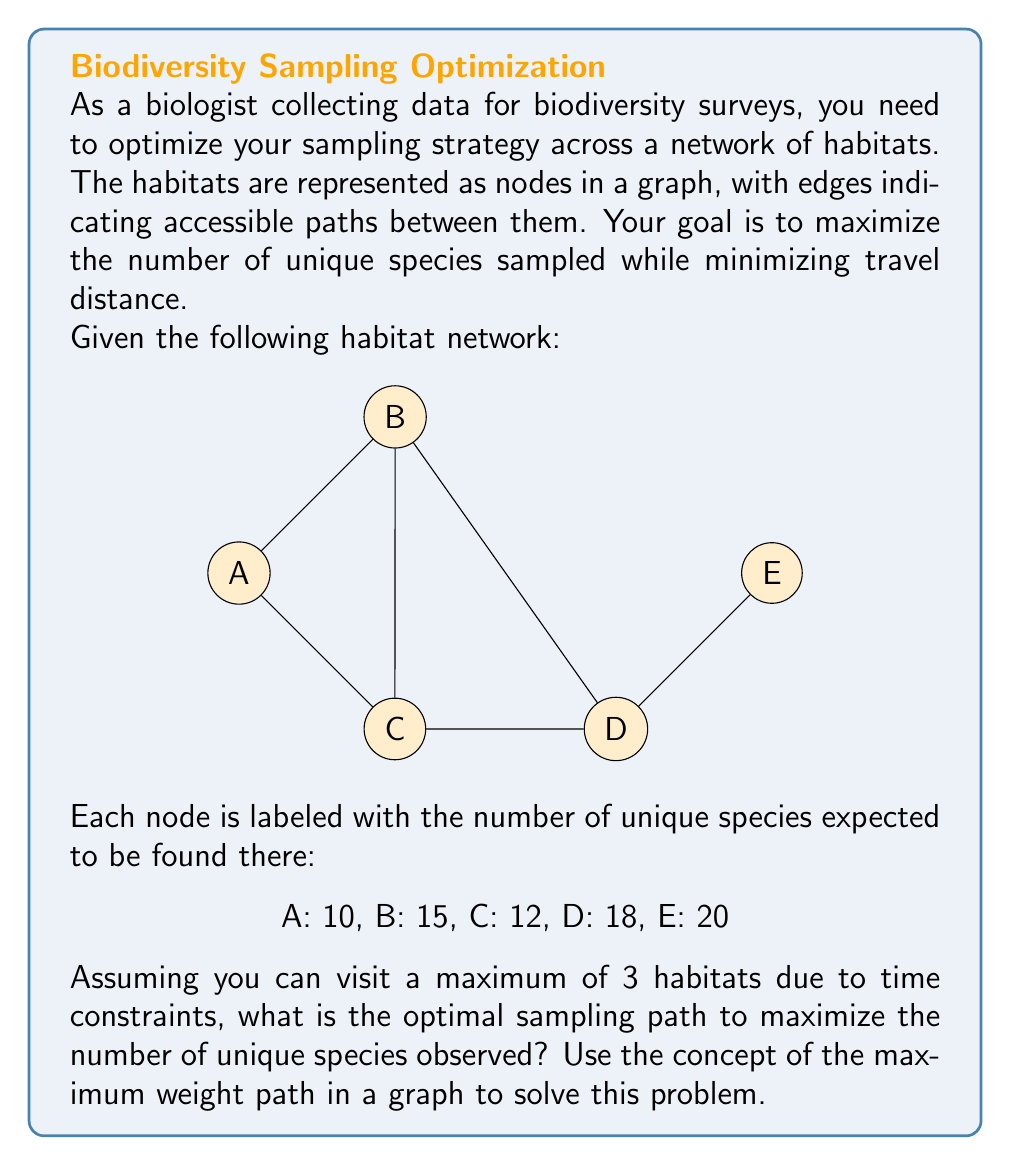Can you solve this math problem? To solve this problem, we'll use the concept of the maximum weight path in a graph. Here's a step-by-step approach:

1) First, we need to create a weighted graph where the weights represent the number of unique species at each node.

2) Since we can only visit 3 habitats, we're looking for the path of length 2 (3 nodes) with the maximum total weight.

3) Let's list all possible paths of length 2:
   A-B-D, A-B-E, A-C-D, B-C-D, B-D-E, C-D-E

4) Now, let's calculate the total weight (number of species) for each path:
   A-B-D: 10 + 15 + 18 = 43
   A-B-E: 10 + 15 + 20 = 45
   A-C-D: 10 + 12 + 18 = 40
   B-C-D: 15 + 12 + 18 = 45
   B-D-E: 15 + 18 + 20 = 53
   C-D-E: 12 + 18 + 20 = 50

5) The path with the maximum weight is B-D-E, with a total of 53 unique species.

6) This path can be represented mathematically as:

   $$P_{max} = \arg\max_{P \in \text{Paths}} \sum_{v \in P} w(v)$$

   where $P_{max}$ is the optimal path, Paths is the set of all possible paths, $v$ represents the nodes in the path, and $w(v)$ is the weight (number of species) at node $v$.

Therefore, the optimal sampling path to maximize the number of unique species observed is B-D-E.
Answer: B-D-E 